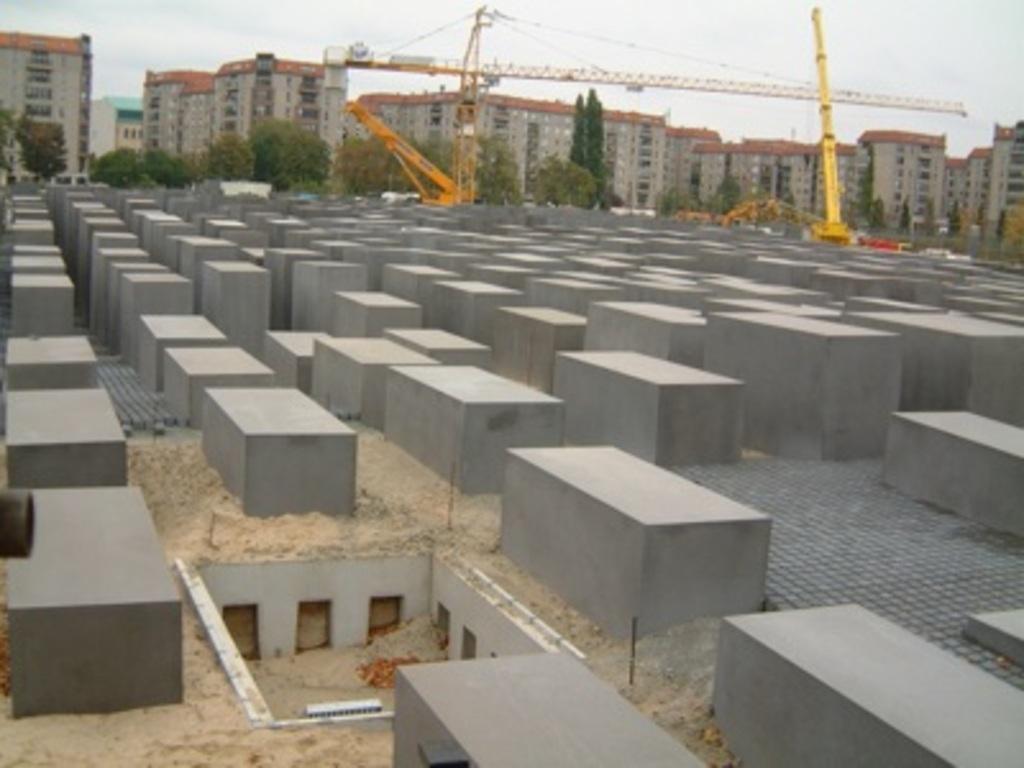Could you give a brief overview of what you see in this image? In this image, we can see some blocks on the ground. There is a crane beside trees. There are some building and sky at the top of the image. 